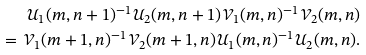Convert formula to latex. <formula><loc_0><loc_0><loc_500><loc_500>\mathcal { U } _ { 1 } ( m , n + 1 ) ^ { - 1 } \mathcal { U } _ { 2 } ( m , n + 1 ) \mathcal { V } _ { 1 } ( m , n ) ^ { - 1 } \mathcal { V } _ { 2 } ( m , n ) \\ = \mathcal { V } _ { 1 } ( m + 1 , n ) ^ { - 1 } \mathcal { V } _ { 2 } ( m + 1 , n ) \mathcal { U } _ { 1 } ( m , n ) ^ { - 1 } \mathcal { U } _ { 2 } ( m , n ) .</formula> 